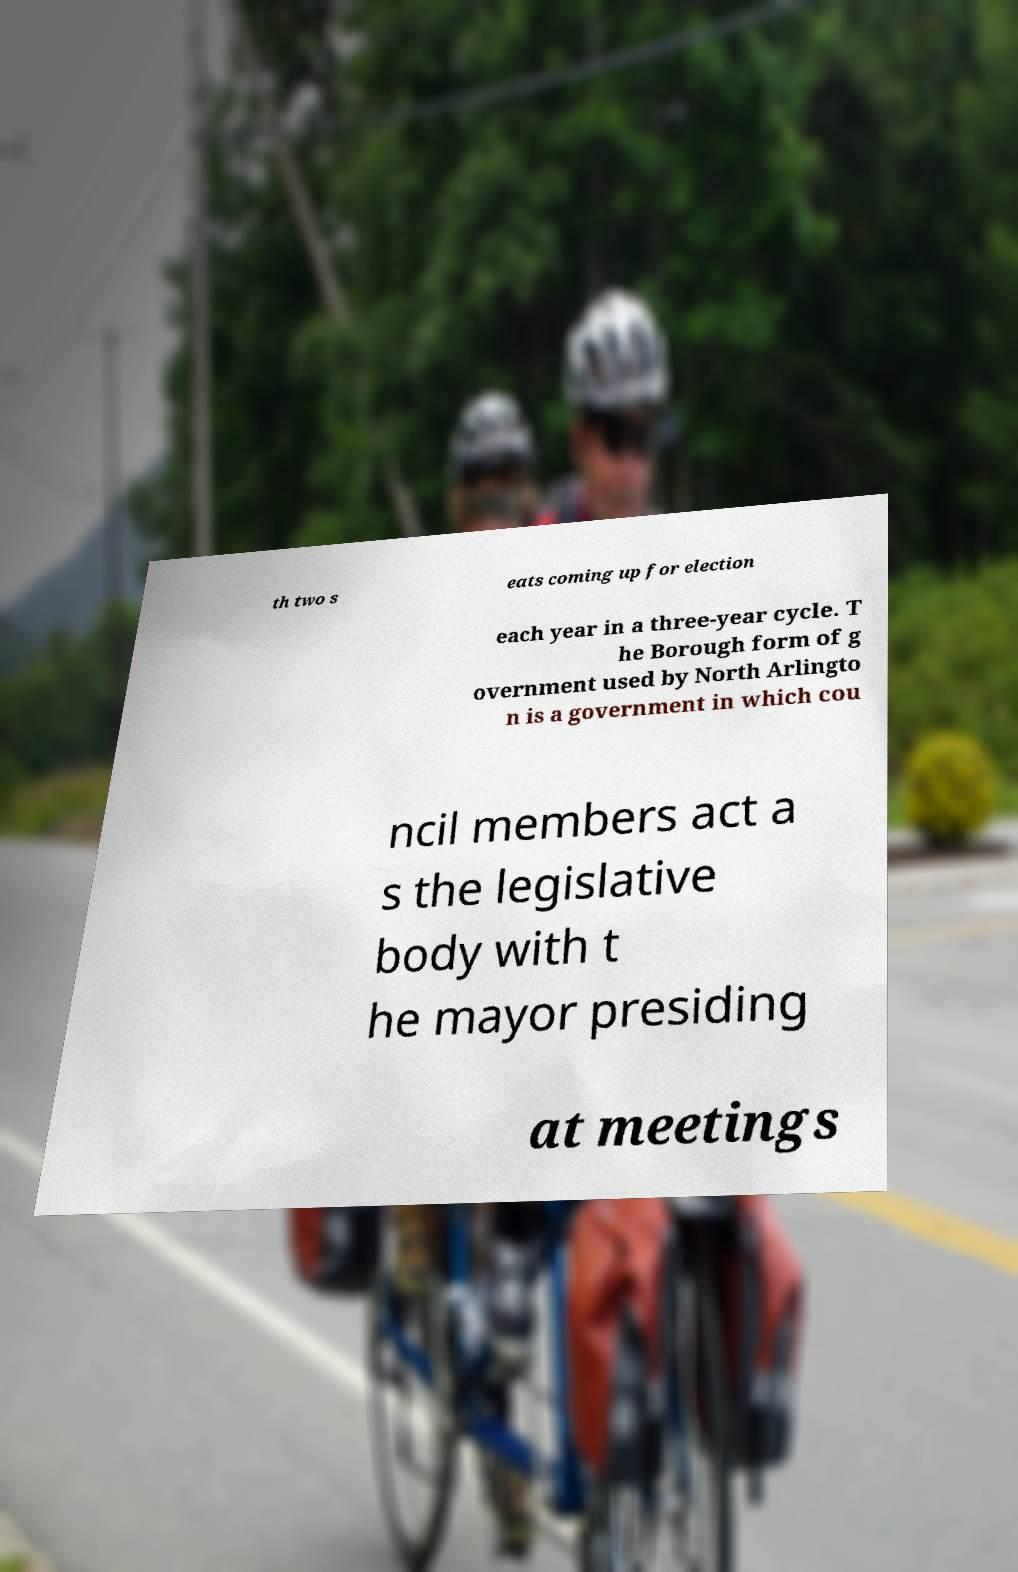I need the written content from this picture converted into text. Can you do that? th two s eats coming up for election each year in a three-year cycle. T he Borough form of g overnment used by North Arlingto n is a government in which cou ncil members act a s the legislative body with t he mayor presiding at meetings 